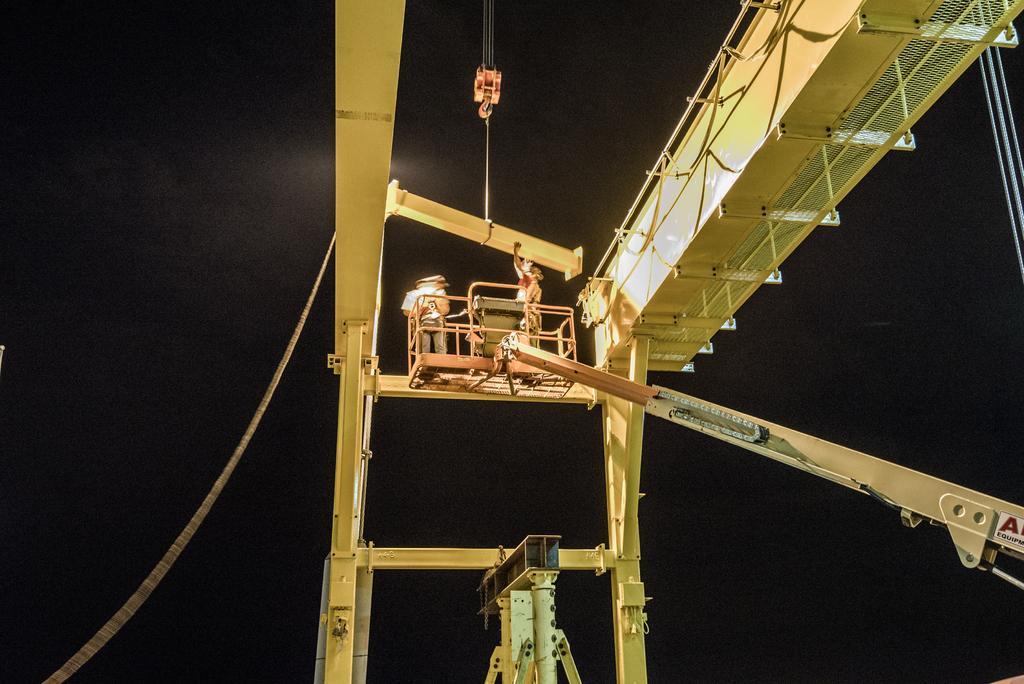Describe this image in one or two sentences. In this image we can see a crane, there are some people and metal rods, also we can see the background is dark. 